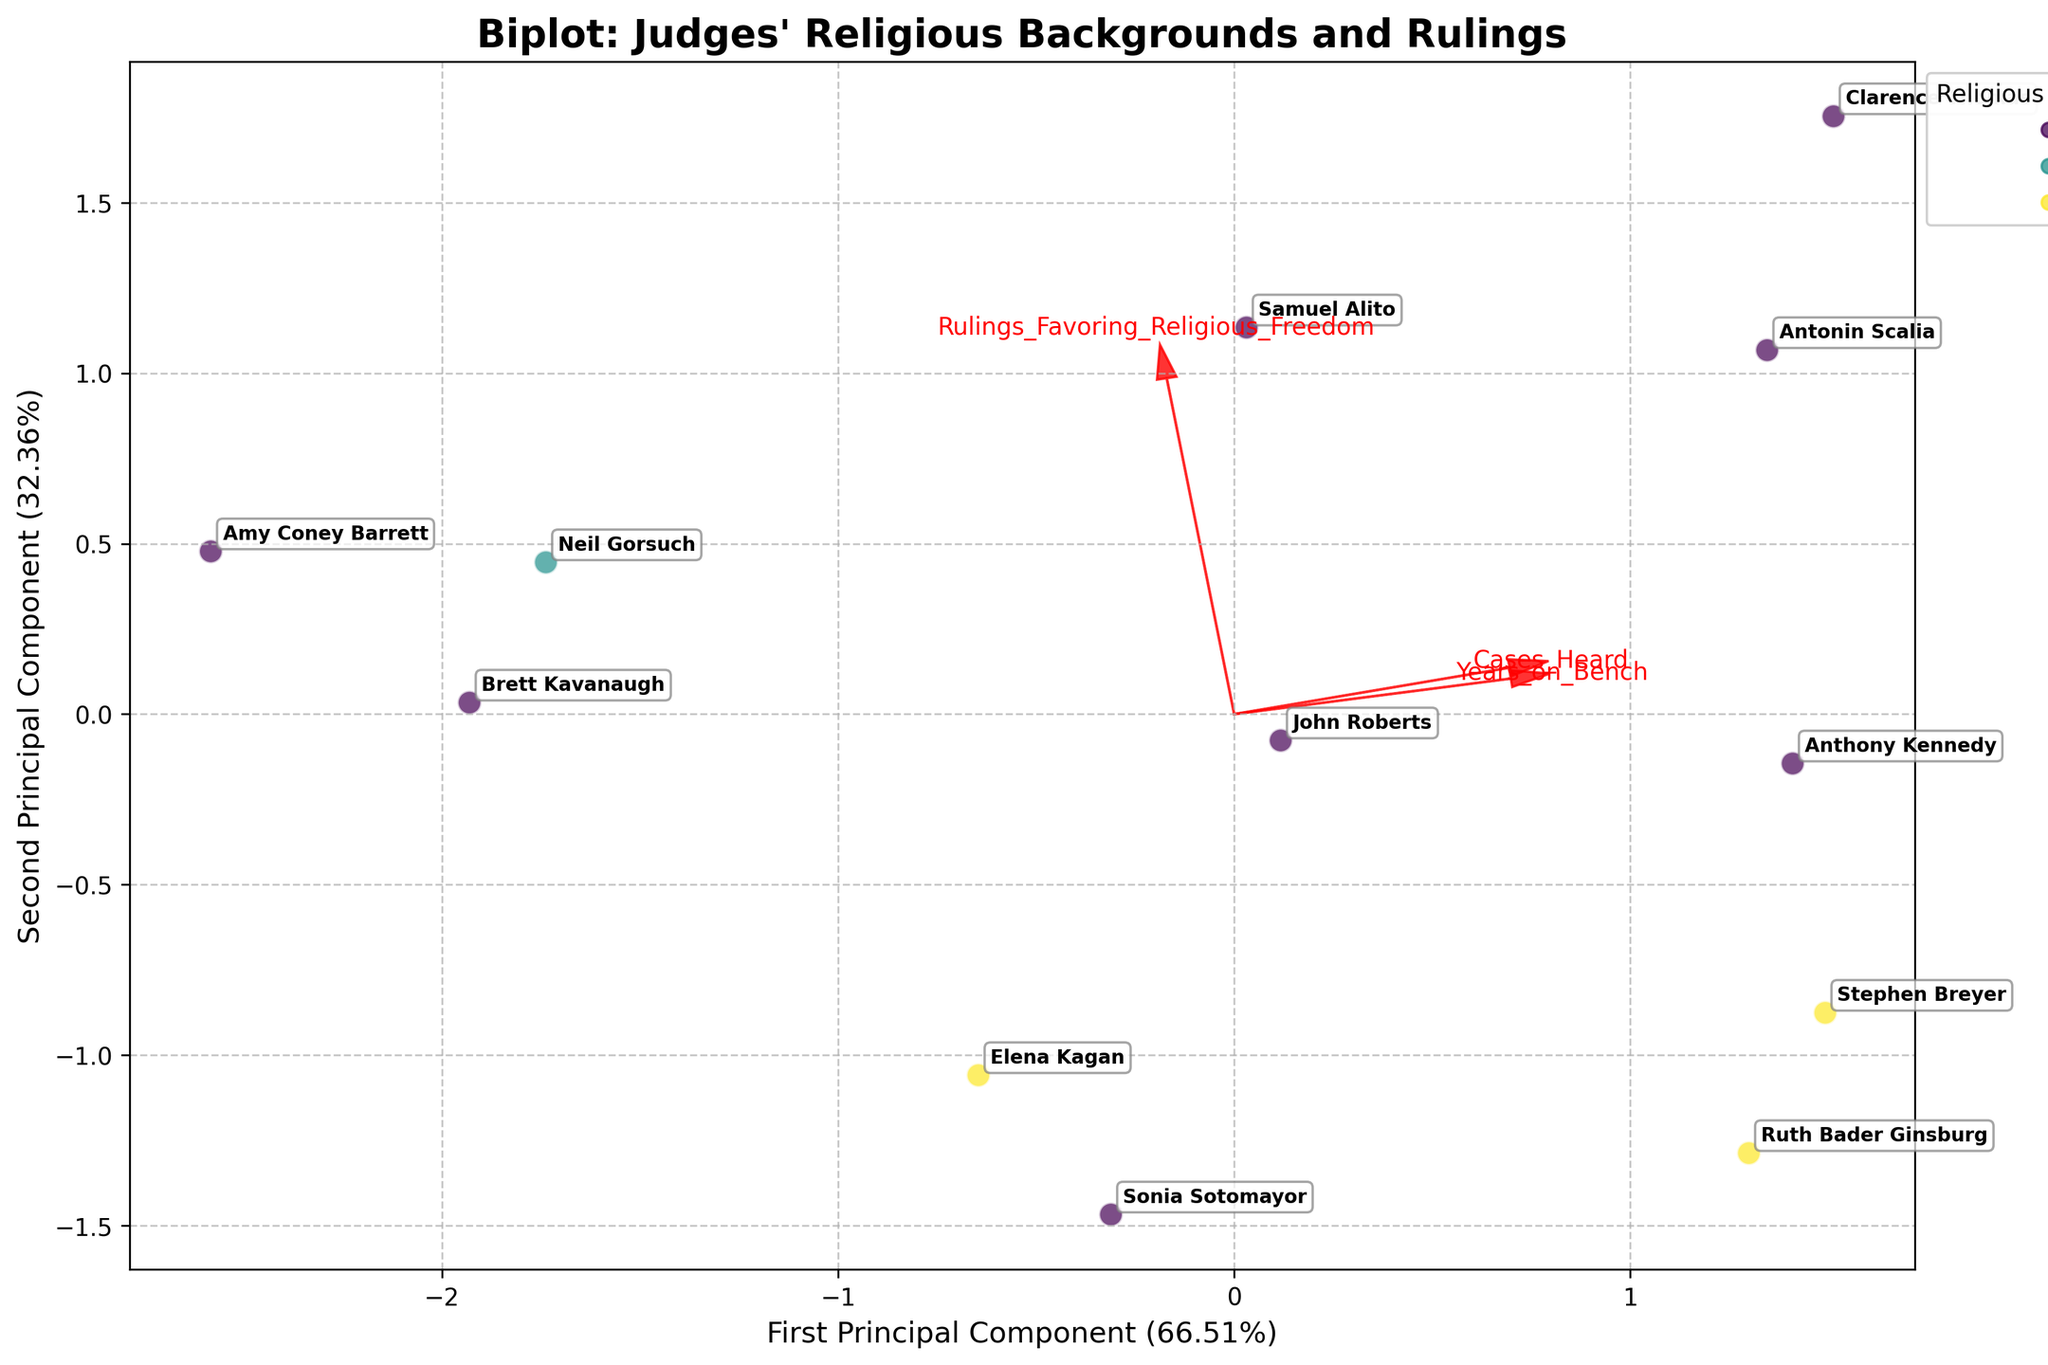What religious background has the majority of judges? The scatter plot uses different colors to represent various religious backgrounds. By counting the number of data points for each color, it's evident that most data points correspond to Catholic judges.
Answer: Catholic Which judge has the highest value for 'Rulings Favoring Religious Freedom'? By checking the annotations near the highest value on the 'Rulings Favoring Religious Freedom' arrow, Clarence Thomas stands out as having a value of 0.89.
Answer: Clarence Thomas How many judges have a 'Rulings Favoring Religious Freedom' value greater than 0.80? Identify the position of the 'Rulings Favoring Religious Freedom' arrow and count the data points (judges) annotated near values higher than 0.80. These are Neil Gorsuch, Samuel Alito, Clarence Thomas, Antonin Scalia, Amy Coney Barrett, and Brett Kavanaugh.
Answer: 6 Which religious background has the least variance in 'Years on Bench'? Observing the spread of data points along the 'Years on Bench' arrow, we can see that Jewish judges have a narrower range of 'Years on Bench' values compared to Catholics and Episcopalians.
Answer: Jewish Are there any judges with similar principal components but different religious backgrounds? By comparing the locations of data points with different annotations but close proximity in the biplot, we can see that Stephen Breyer (Jewish) and Anthony Kennedy (Catholic) are close to each other on the plot.
Answer: Yes Which feature vector seems to contribute most to the First Principal Component? The PCA feature vectors' directions and lengths indicate their contribution. The 'Rulings Favoring Religious Freedom' vector has the longest arrow along the First Principal Component axis, suggesting its highest contribution.
Answer: 'Rulings Favoring Religious Freedom' How many different religious backgrounds are represented in the plot? The legend shows different religious backgrounds used in the scatter plot. Counting the unique categories listed, there are three religious backgrounds: Catholic, Jewish, and Episcopalian.
Answer: 3 Which judge has the longest tenure on the bench and what is his religious background? By checking the annotation closest to the highest value on the 'Years on Bench' arrow, Clarence Thomas is identified, and he is a Catholic.
Answer: Clarence Thomas; Catholic Are there any judges with high 'Cases_Heard' but low 'Rulings_Favoring_Religious_Freedom'? By examining positions along the 'Cases_Heard' arrow and checking their 'Rulings Favoring Religious Freedom' positions, Ruth Bader Ginsburg has high 'Cases_Heard' but lower 'Rulings Favoring Religious Freedom'.
Answer: Yes, Ruth Bader Ginsburg 